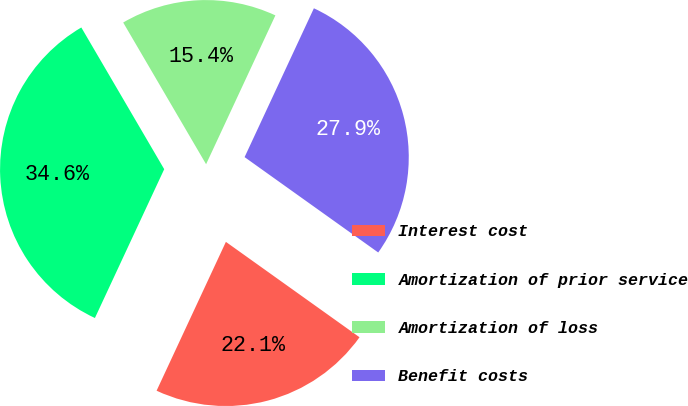<chart> <loc_0><loc_0><loc_500><loc_500><pie_chart><fcel>Interest cost<fcel>Amortization of prior service<fcel>Amortization of loss<fcel>Benefit costs<nl><fcel>22.07%<fcel>34.64%<fcel>15.36%<fcel>27.93%<nl></chart> 